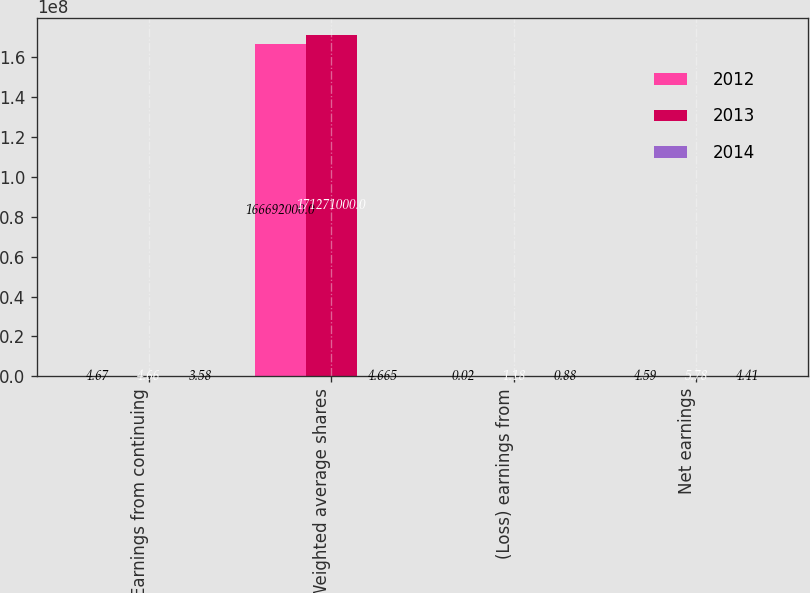Convert chart. <chart><loc_0><loc_0><loc_500><loc_500><stacked_bar_chart><ecel><fcel>Earnings from continuing<fcel>Weighted average shares<fcel>(Loss) earnings from<fcel>Net earnings<nl><fcel>2012<fcel>4.67<fcel>1.66692e+08<fcel>0.02<fcel>4.59<nl><fcel>2013<fcel>4.66<fcel>1.71271e+08<fcel>1.18<fcel>5.78<nl><fcel>2014<fcel>3.58<fcel>4.665<fcel>0.88<fcel>4.41<nl></chart> 